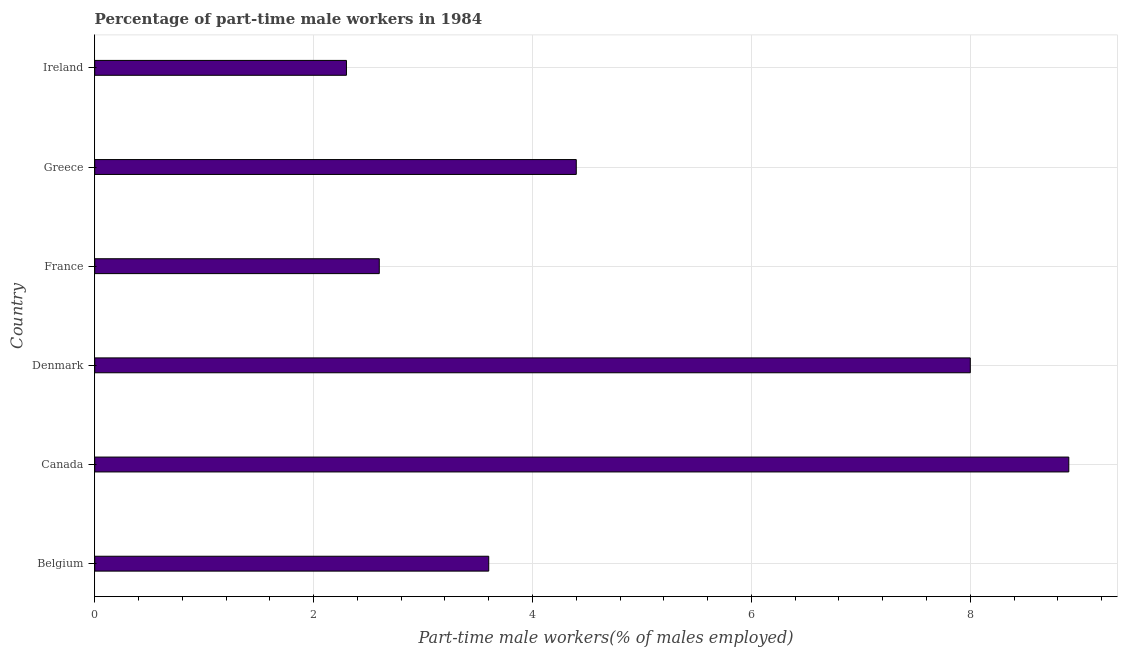Does the graph contain any zero values?
Your answer should be compact. No. What is the title of the graph?
Your answer should be very brief. Percentage of part-time male workers in 1984. What is the label or title of the X-axis?
Keep it short and to the point. Part-time male workers(% of males employed). What is the percentage of part-time male workers in Ireland?
Your answer should be very brief. 2.3. Across all countries, what is the maximum percentage of part-time male workers?
Your answer should be compact. 8.9. Across all countries, what is the minimum percentage of part-time male workers?
Give a very brief answer. 2.3. In which country was the percentage of part-time male workers maximum?
Make the answer very short. Canada. In which country was the percentage of part-time male workers minimum?
Offer a terse response. Ireland. What is the sum of the percentage of part-time male workers?
Keep it short and to the point. 29.8. What is the difference between the percentage of part-time male workers in Denmark and France?
Provide a short and direct response. 5.4. What is the average percentage of part-time male workers per country?
Provide a succinct answer. 4.97. In how many countries, is the percentage of part-time male workers greater than 0.4 %?
Your answer should be very brief. 6. What is the ratio of the percentage of part-time male workers in Denmark to that in Greece?
Make the answer very short. 1.82. What is the difference between the highest and the lowest percentage of part-time male workers?
Your response must be concise. 6.6. In how many countries, is the percentage of part-time male workers greater than the average percentage of part-time male workers taken over all countries?
Provide a succinct answer. 2. How many bars are there?
Ensure brevity in your answer.  6. Are all the bars in the graph horizontal?
Offer a terse response. Yes. Are the values on the major ticks of X-axis written in scientific E-notation?
Offer a terse response. No. What is the Part-time male workers(% of males employed) in Belgium?
Make the answer very short. 3.6. What is the Part-time male workers(% of males employed) of Canada?
Give a very brief answer. 8.9. What is the Part-time male workers(% of males employed) of Denmark?
Ensure brevity in your answer.  8. What is the Part-time male workers(% of males employed) of France?
Your answer should be compact. 2.6. What is the Part-time male workers(% of males employed) of Greece?
Ensure brevity in your answer.  4.4. What is the Part-time male workers(% of males employed) in Ireland?
Offer a very short reply. 2.3. What is the difference between the Part-time male workers(% of males employed) in Belgium and Canada?
Offer a very short reply. -5.3. What is the difference between the Part-time male workers(% of males employed) in Denmark and France?
Ensure brevity in your answer.  5.4. What is the difference between the Part-time male workers(% of males employed) in Denmark and Greece?
Provide a succinct answer. 3.6. What is the difference between the Part-time male workers(% of males employed) in France and Ireland?
Your answer should be very brief. 0.3. What is the difference between the Part-time male workers(% of males employed) in Greece and Ireland?
Offer a very short reply. 2.1. What is the ratio of the Part-time male workers(% of males employed) in Belgium to that in Canada?
Your answer should be compact. 0.4. What is the ratio of the Part-time male workers(% of males employed) in Belgium to that in Denmark?
Your response must be concise. 0.45. What is the ratio of the Part-time male workers(% of males employed) in Belgium to that in France?
Your answer should be very brief. 1.39. What is the ratio of the Part-time male workers(% of males employed) in Belgium to that in Greece?
Offer a terse response. 0.82. What is the ratio of the Part-time male workers(% of males employed) in Belgium to that in Ireland?
Provide a succinct answer. 1.56. What is the ratio of the Part-time male workers(% of males employed) in Canada to that in Denmark?
Keep it short and to the point. 1.11. What is the ratio of the Part-time male workers(% of males employed) in Canada to that in France?
Make the answer very short. 3.42. What is the ratio of the Part-time male workers(% of males employed) in Canada to that in Greece?
Ensure brevity in your answer.  2.02. What is the ratio of the Part-time male workers(% of males employed) in Canada to that in Ireland?
Offer a very short reply. 3.87. What is the ratio of the Part-time male workers(% of males employed) in Denmark to that in France?
Provide a succinct answer. 3.08. What is the ratio of the Part-time male workers(% of males employed) in Denmark to that in Greece?
Give a very brief answer. 1.82. What is the ratio of the Part-time male workers(% of males employed) in Denmark to that in Ireland?
Offer a very short reply. 3.48. What is the ratio of the Part-time male workers(% of males employed) in France to that in Greece?
Make the answer very short. 0.59. What is the ratio of the Part-time male workers(% of males employed) in France to that in Ireland?
Offer a terse response. 1.13. What is the ratio of the Part-time male workers(% of males employed) in Greece to that in Ireland?
Your answer should be very brief. 1.91. 